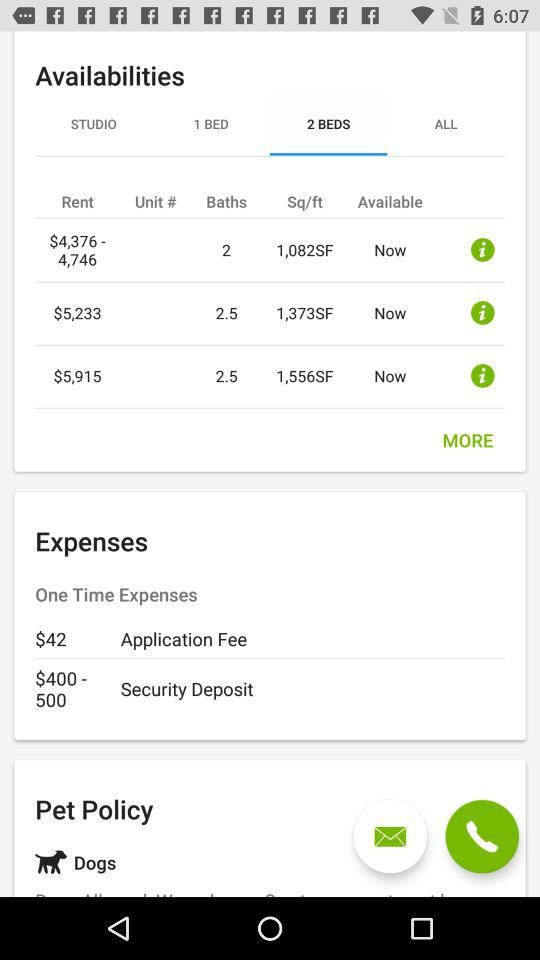What is the selected option? The selected option is "2 BEDS". 